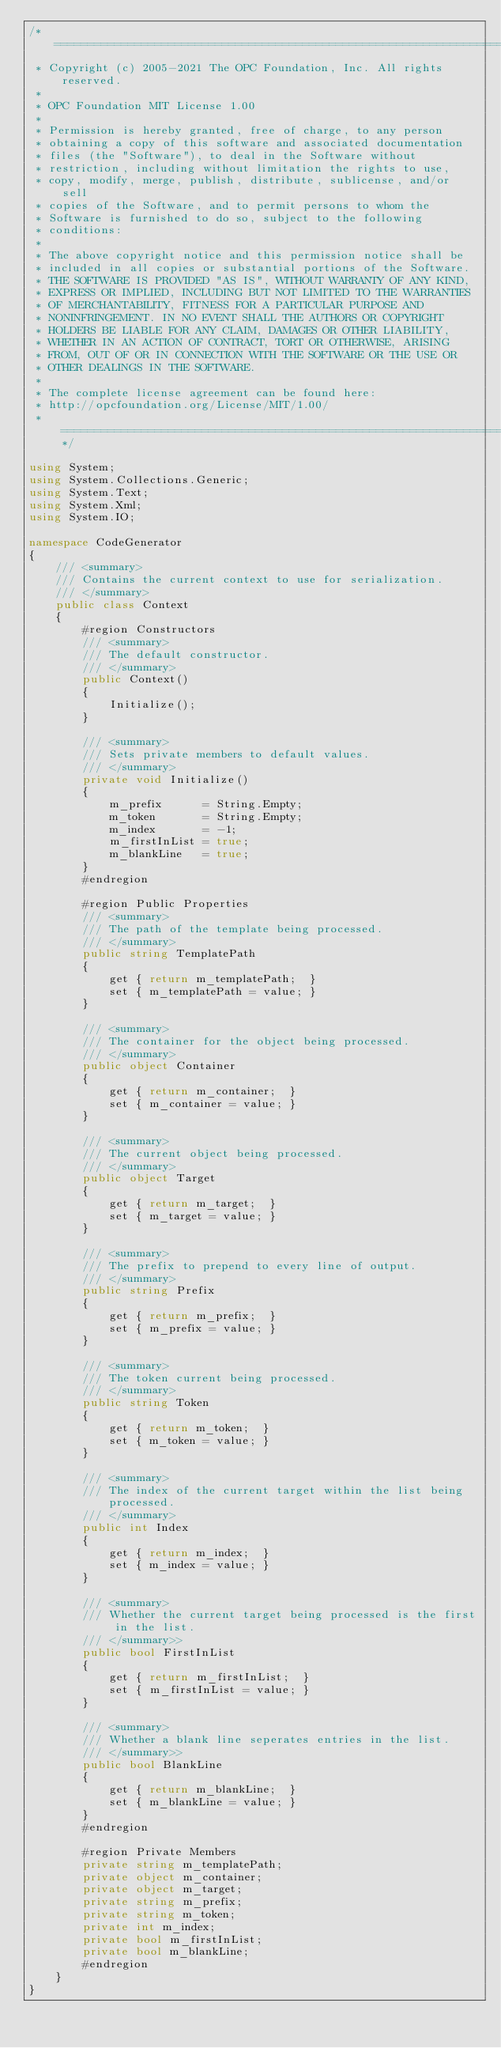Convert code to text. <code><loc_0><loc_0><loc_500><loc_500><_C#_>/* ========================================================================
 * Copyright (c) 2005-2021 The OPC Foundation, Inc. All rights reserved.
 *
 * OPC Foundation MIT License 1.00
 *
 * Permission is hereby granted, free of charge, to any person
 * obtaining a copy of this software and associated documentation
 * files (the "Software"), to deal in the Software without
 * restriction, including without limitation the rights to use,
 * copy, modify, merge, publish, distribute, sublicense, and/or sell
 * copies of the Software, and to permit persons to whom the
 * Software is furnished to do so, subject to the following
 * conditions:
 *
 * The above copyright notice and this permission notice shall be
 * included in all copies or substantial portions of the Software.
 * THE SOFTWARE IS PROVIDED "AS IS", WITHOUT WARRANTY OF ANY KIND,
 * EXPRESS OR IMPLIED, INCLUDING BUT NOT LIMITED TO THE WARRANTIES
 * OF MERCHANTABILITY, FITNESS FOR A PARTICULAR PURPOSE AND
 * NONINFRINGEMENT. IN NO EVENT SHALL THE AUTHORS OR COPYRIGHT
 * HOLDERS BE LIABLE FOR ANY CLAIM, DAMAGES OR OTHER LIABILITY,
 * WHETHER IN AN ACTION OF CONTRACT, TORT OR OTHERWISE, ARISING
 * FROM, OUT OF OR IN CONNECTION WITH THE SOFTWARE OR THE USE OR
 * OTHER DEALINGS IN THE SOFTWARE.
 *
 * The complete license agreement can be found here:
 * http://opcfoundation.org/License/MIT/1.00/
 * ======================================================================*/

using System;
using System.Collections.Generic;
using System.Text;
using System.Xml;
using System.IO;

namespace CodeGenerator
{
    /// <summary>
    /// Contains the current context to use for serialization.
    /// </summary>
    public class Context
    {
        #region Constructors
        /// <summary>
        /// The default constructor.
        /// </summary>
        public Context()
        {
            Initialize();
        }

        /// <summary>
        /// Sets private members to default values.
        /// </summary>
        private void Initialize()
        {
            m_prefix      = String.Empty;
            m_token       = String.Empty;
            m_index       = -1;
            m_firstInList = true;
            m_blankLine   = true;
        }
        #endregion

        #region Public Properties
        /// <summary>
        /// The path of the template being processed.
        /// </summary>
        public string TemplatePath
        {
            get { return m_templatePath;  }
            set { m_templatePath = value; }
        }

        /// <summary>
        /// The container for the object being processed.
        /// </summary>
        public object Container
        {
            get { return m_container;  }
            set { m_container = value; }
        }

        /// <summary>
        /// The current object being processed.
        /// </summary>
        public object Target
        {
            get { return m_target;  }
            set { m_target = value; }
        }

        /// <summary>
        /// The prefix to prepend to every line of output.
        /// </summary>
        public string Prefix
        {
            get { return m_prefix;  }
            set { m_prefix = value; }
        }

        /// <summary>
        /// The token current being processed.
        /// </summary>
        public string Token
        {
            get { return m_token;  }
            set { m_token = value; }
        }

        /// <summary>
        /// The index of the current target within the list being processed.
        /// </summary>
        public int Index
        {
            get { return m_index;  }
            set { m_index = value; }
        }

        /// <summary>
        /// Whether the current target being processed is the first in the list.
        /// </summary>>
        public bool FirstInList
        {
            get { return m_firstInList;  }
            set { m_firstInList = value; }
        }

        /// <summary>
        /// Whether a blank line seperates entries in the list.
        /// </summary>>
        public bool BlankLine
        {
            get { return m_blankLine;  }
            set { m_blankLine = value; }
        }
        #endregion

        #region Private Members
        private string m_templatePath;
        private object m_container;
        private object m_target;
        private string m_prefix;
        private string m_token;
        private int m_index;
        private bool m_firstInList;
        private bool m_blankLine;
        #endregion
    }
}
</code> 